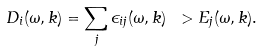Convert formula to latex. <formula><loc_0><loc_0><loc_500><loc_500>D _ { i } ( \omega , { k } ) = \sum _ { j } \epsilon _ { i j } ( \omega , { k } ) \ > E _ { j } ( \omega , { k } ) .</formula> 